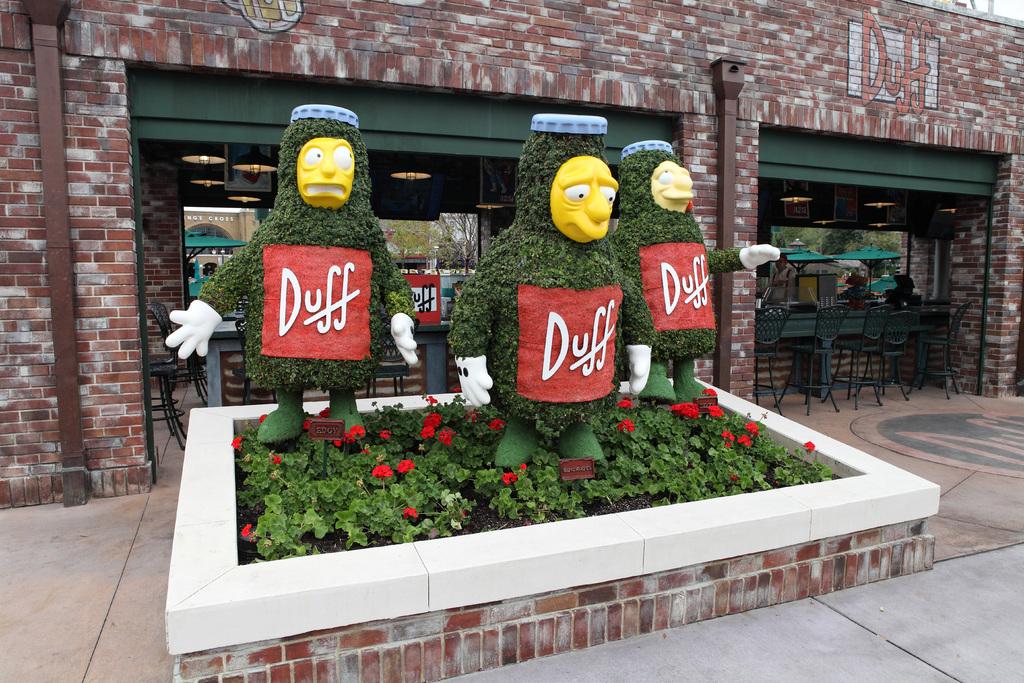What is the name of the store?
Your answer should be very brief. Duff. What brand is advertised on the tree?
Provide a short and direct response. Duff. 